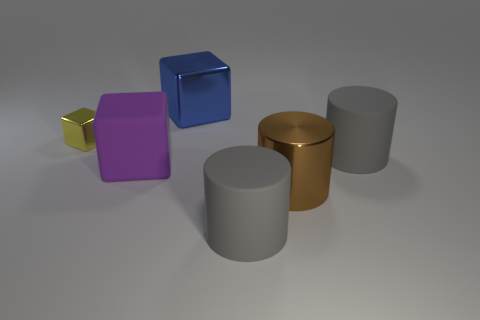What shapes are present in the image and how are they positioned relative to each other? There are two cubes and four cylinders. The yellow cube is the farthest to the left and slightly in front of the purple cube. The blue cube is to the right of the purple cube and slightly behind it. The brown and gold cylinders are next to each other in the center-right of the image, and the two gray cylinders are to the right of all other objects. 